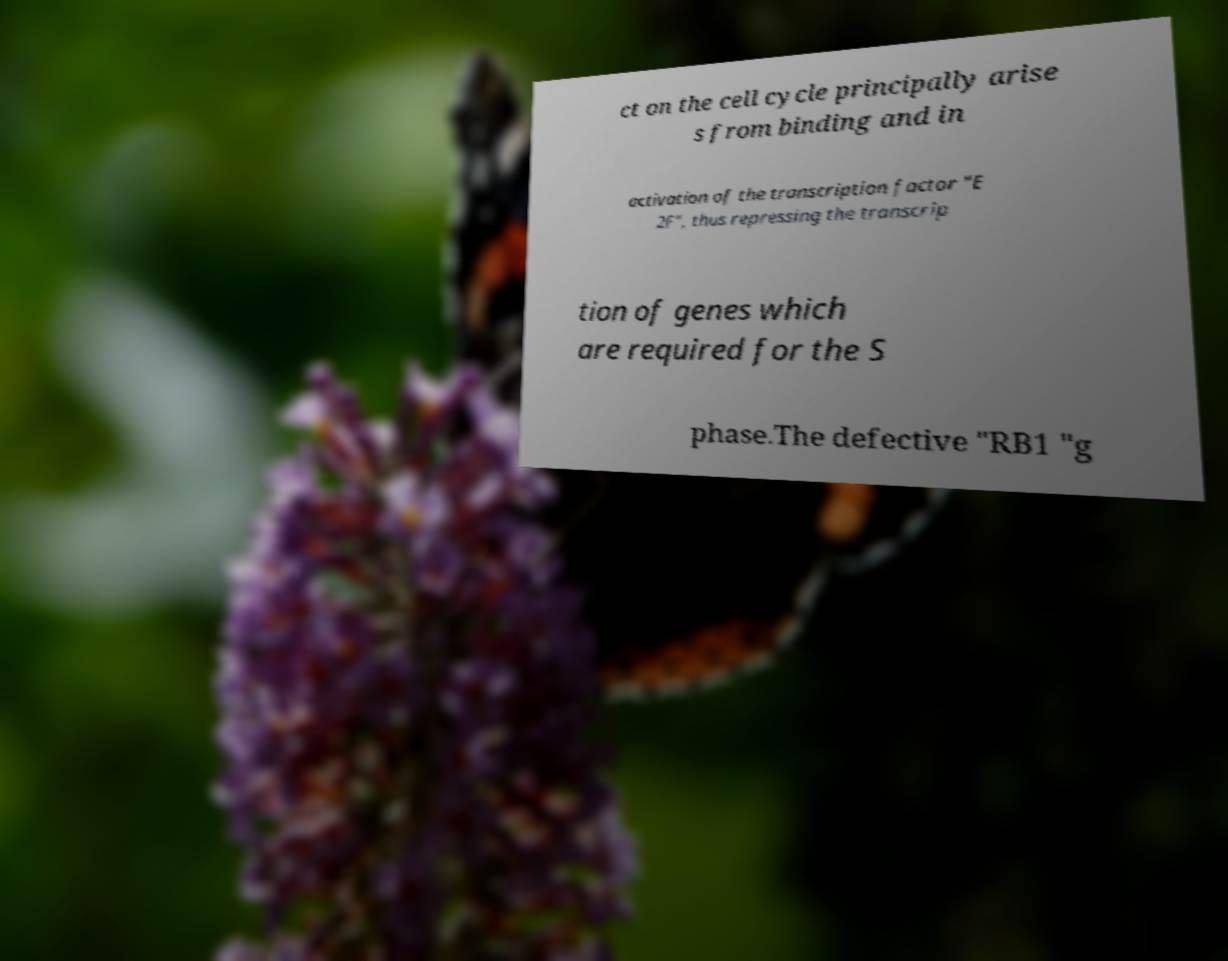Could you extract and type out the text from this image? ct on the cell cycle principally arise s from binding and in activation of the transcription factor "E 2F", thus repressing the transcrip tion of genes which are required for the S phase.The defective "RB1 "g 